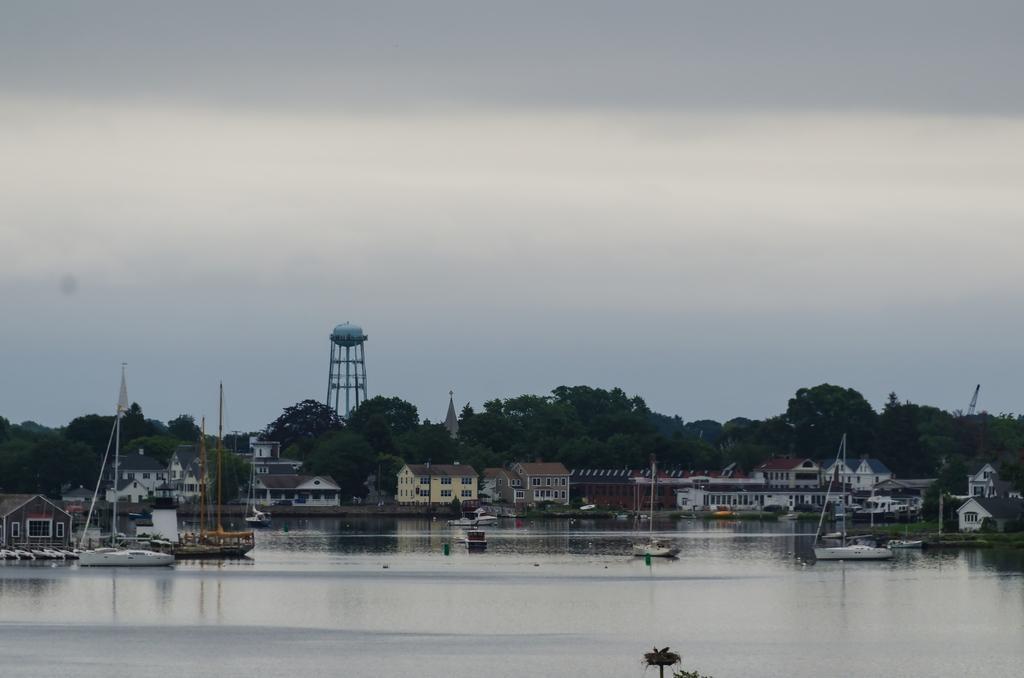In one or two sentences, can you explain what this image depicts? In this image I can see few boats on the water, background I can see few buildings in white, cream and brown color, trees in green color and the sky is in white color. 